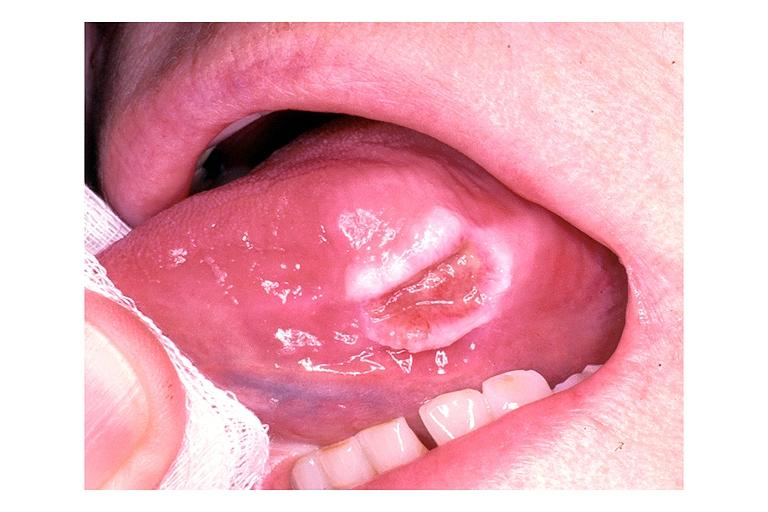s pharynx present?
Answer the question using a single word or phrase. No 